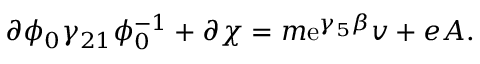Convert formula to latex. <formula><loc_0><loc_0><loc_500><loc_500>\partial \phi _ { 0 } \gamma _ { 2 1 } \phi _ { 0 } ^ { - 1 } + \partial \chi = m e ^ { \gamma _ { 5 } \beta } v + e A .</formula> 